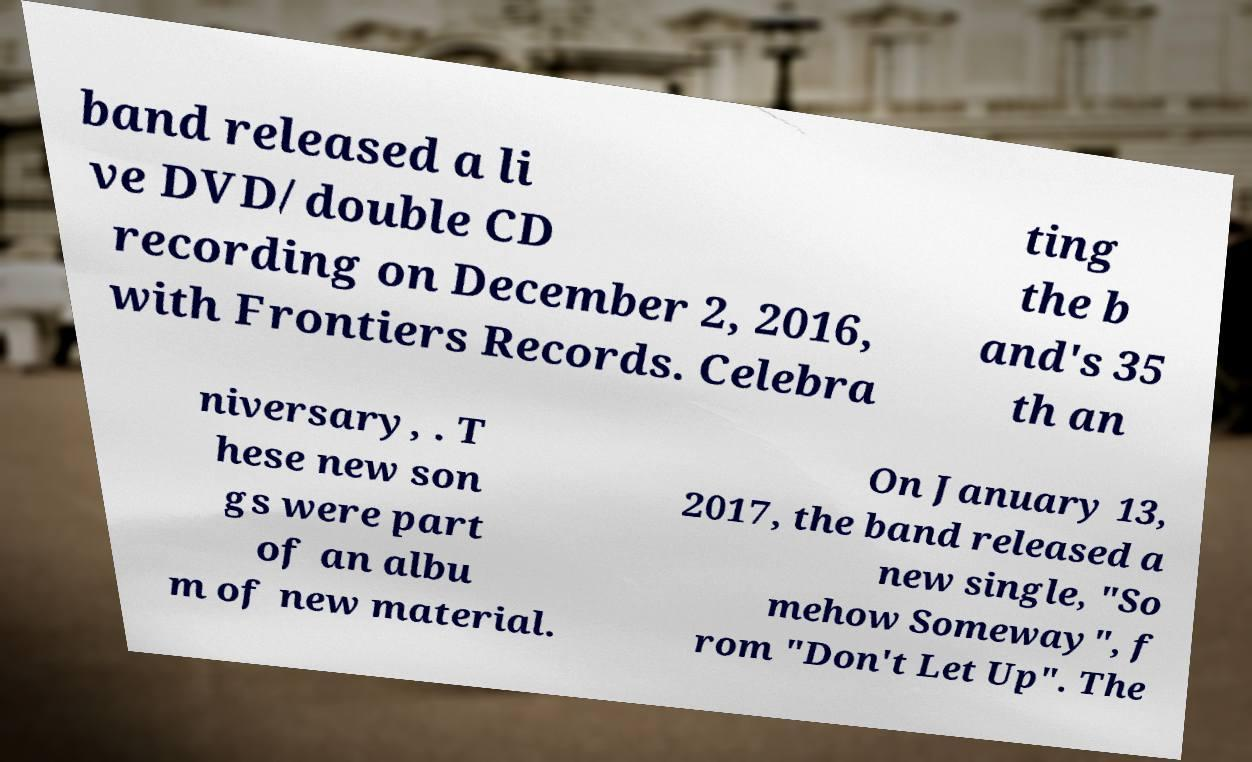For documentation purposes, I need the text within this image transcribed. Could you provide that? band released a li ve DVD/double CD recording on December 2, 2016, with Frontiers Records. Celebra ting the b and's 35 th an niversary, . T hese new son gs were part of an albu m of new material. On January 13, 2017, the band released a new single, "So mehow Someway", f rom "Don't Let Up". The 